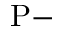Convert formula to latex. <formula><loc_0><loc_0><loc_500><loc_500>P -</formula> 